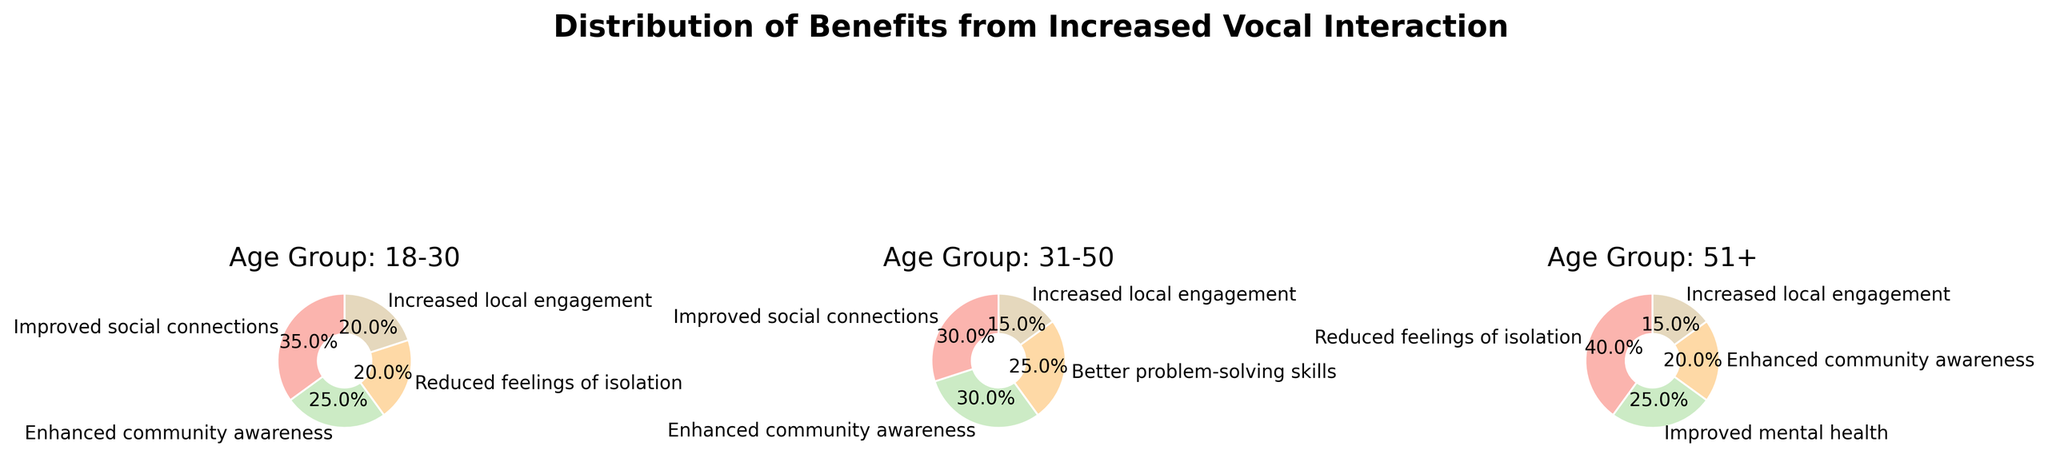What is the title of the figure? The title of the figure is located at the top of the plot. It serves as a summary description of what the figure represents.
Answer: Distribution of Benefits from Increased Vocal Interaction Which age group has the highest percentage of respondents reporting "Improved social connections"? Look at the pie charts for each age group and identify the segment labeled "Improved social connections." Compare the percentages reported in each pie chart.
Answer: 18-30 What is the combined percentage of "Increased local engagement" for all age groups? Sum the percentages labeled "Increased local engagement" from all three pie charts. For 18-30 it is 20%, for 31-50 it is 15%, and for 51+ it is 15%. 20% + 15% + 15% = 50%
Answer: 50% Which benefit is unique to the age group 31-50? Identify each benefit in the 31-50 age group's pie chart and cross-reference it with the benefits in other age groups to find the unique one. Only "Better problem-solving skills" is reported for the 31-50 age group and not in the other two.
Answer: Better problem-solving skills How does the percentage of "Enhanced community awareness" compare across the age groups? Check the percentages of "Enhanced community awareness" in each age group's pie chart. 18-30 has 25%, 31-50 has 30%, and 51+ has 20%.
Answer: 31-50: 30%, 18-30: 25%, 51+: 20% What percentage of the 51+ age group reported "Improved mental health"? Locate the "Improved mental health" segment in the pie chart for the 51+ age group and read the reported percentage.
Answer: 25% Which age group has the largest segment for "Reduced feelings of isolation"? Examine each pie chart for the "Reduced feelings of isolation" segment and find the age group with the largest percentage. The 51+ age group has the largest segment with 40%.
Answer: 51+ How many benefits are reported in the 18-30 age group? Count the number of labeled segments in the pie chart for the 18-30 age group. There are four labeled segments.
Answer: 4 What is the smallest segment by percentage in any age group and which benefit does it correspond to? Examine each pie chart and find the segment with the smallest percentage in any group. The smallest segment is "Increased local engagement" in the 31-50 and 51+ age groups, both at 15%.
Answer: Increased local engagement, 15% 